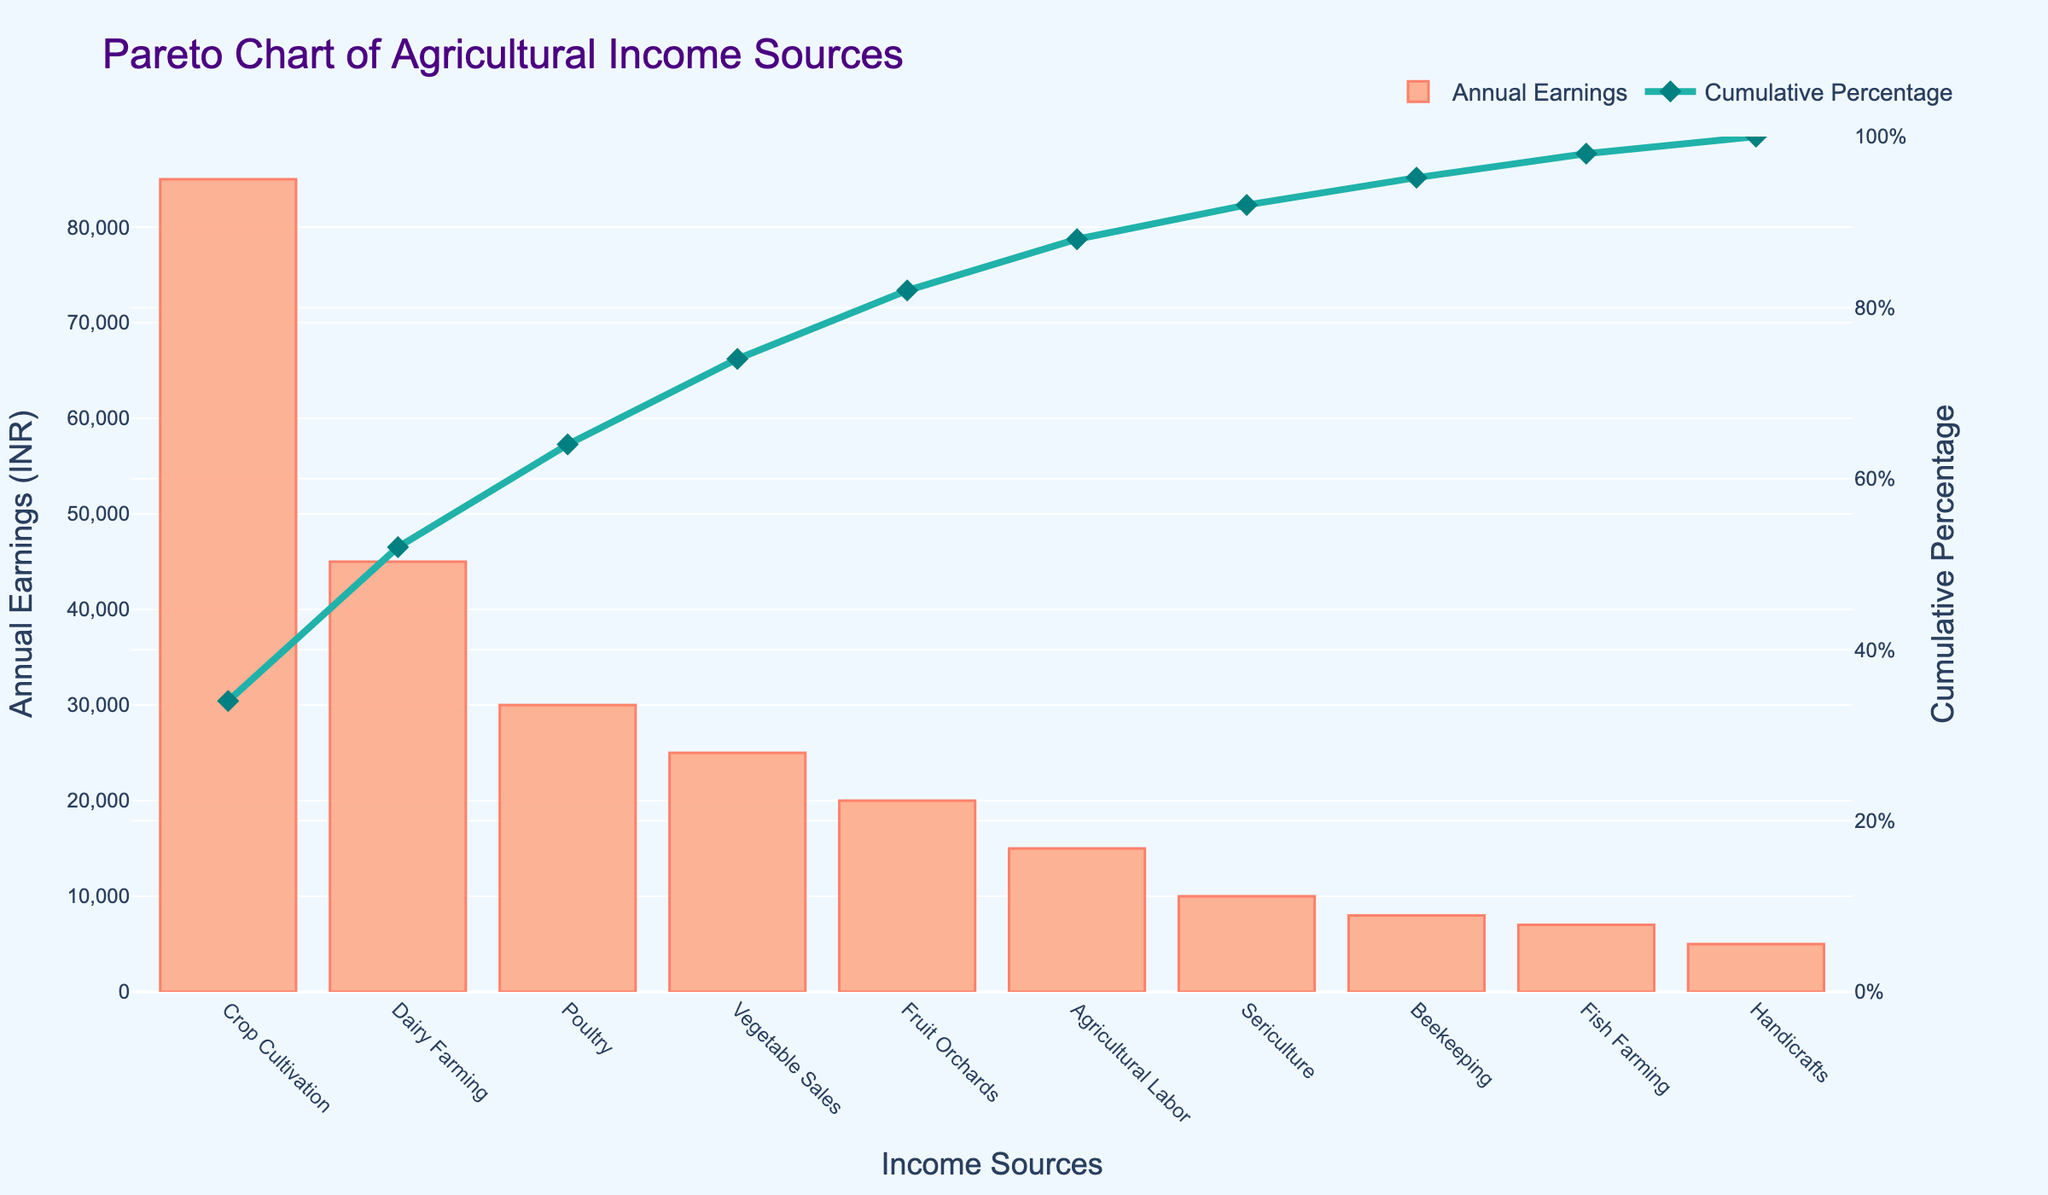What's the title of the chart? The title of the chart is found at the top center and is usually a larger or bold font size. It reads: "Pareto Chart of Agricultural Income Sources."
Answer: Pareto Chart of Agricultural Income Sources What are the two y-axes representing in the chart? The left y-axis (closer to the bars) represents "Annual Earnings (INR)," and the right y-axis (closer to the cumulative percentage line) represents the "Cumulative Percentage," ranging from 0% to 100%.
Answer: Annual Earnings (INR) and Cumulative Percentage Which income source has the highest annual earnings? The highest bar will indicate the highest annual earnings. The chart shows that "Crop Cultivation" has the tallest bar, representing the highest earnings of INR 85,000.
Answer: Crop Cultivation Which income source is the least significant contributor to the total earnings? The smallest bar represents the least significant contributor. The chart shows that "Handicrafts" has the shortest bar with annual earnings of INR 5,000.
Answer: Handicrafts What cumulative percentage is reached by including Dairy Farming? Follow the line plot representing the cumulative percentage up to Dairy Farming on the x-axis. Starting from "Crop Cultivation" and moving to "Dairy Farming," the cumulative percentage reaches around 66%.
Answer: 66% What are the combined annual earnings from Poultry and Vegetable Sales? Add the annual earnings from Poultry (INR 30,000) and Vegetable Sales (INR 25,000). The combined earnings are 30,000 + 25,000 = INR 55,000.
Answer: 55,000 How many income sources have an annual earning of at least INR 20,000? Identify the bars that reach up to and above the INR 20,000 mark on the left y-axis. There are 5 income sources: Crop Cultivation, Dairy Farming, Poultry, Vegetable Sales, and Fruit Orchards.
Answer: 5 By how much do Crop Cultivation earnings exceed the earnings from Beekeeping? Subtract Beekeeping earnings from Crop Cultivation earnings: 85,000 - 8,000 = 77,000.
Answer: 77,000 What is the cumulative percentage when including all income sources up to Agricultural Labor? Follow the cumulative percentage line up to "Agricultural Labor." The cumulative percentage reads approximately 94%.
Answer: 94% At what point does the cumulative percentage surpass 50%, and which income sources contribute to this? The cumulative percentage line surpasses 50% after Dairy Farming. Hence, Crop Cultivation and Dairy Farming contribute to surpassing the 50% mark.
Answer: Crop Cultivation and Dairy Farming 